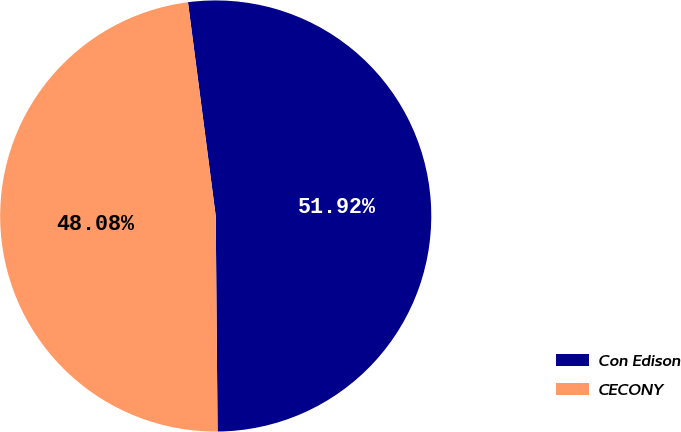Convert chart to OTSL. <chart><loc_0><loc_0><loc_500><loc_500><pie_chart><fcel>Con Edison<fcel>CECONY<nl><fcel>51.92%<fcel>48.08%<nl></chart> 